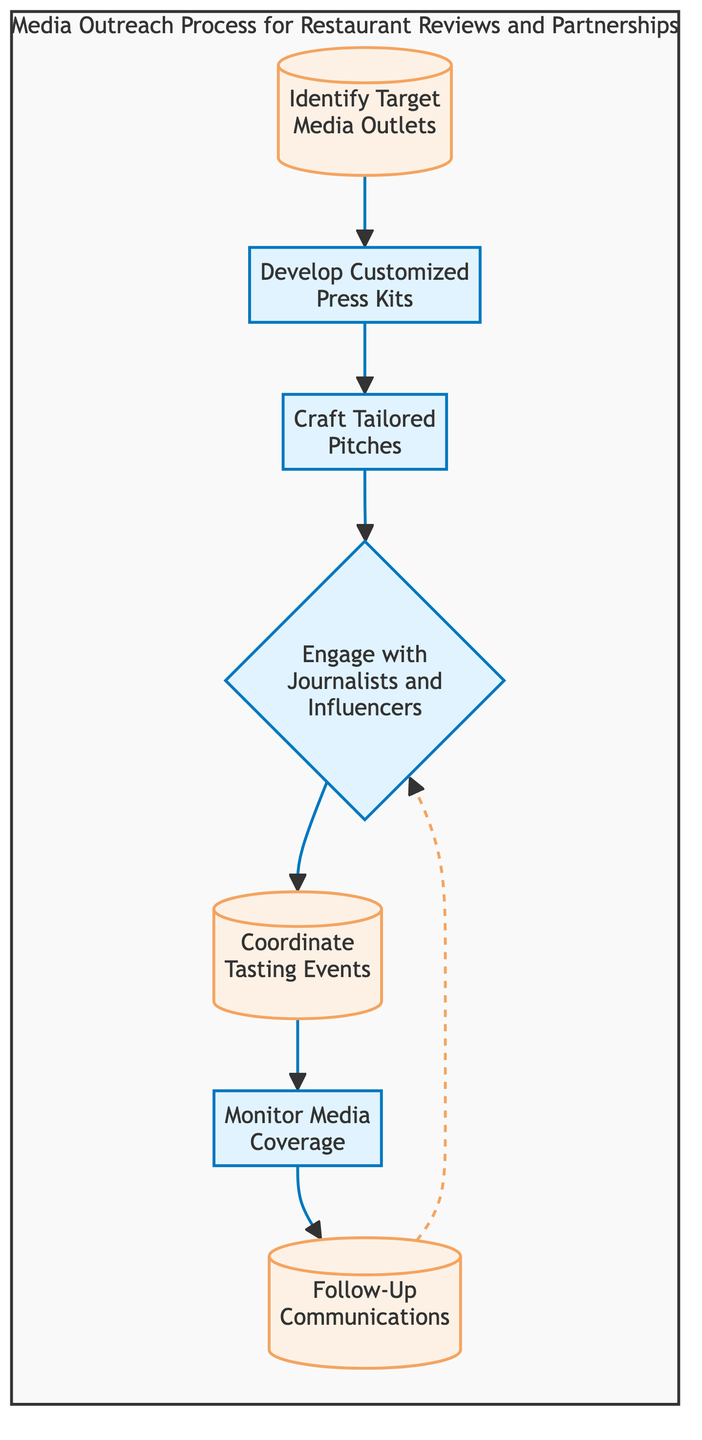What's the first step in the process? The diagram indicates that the first step in the media outreach process is "Identify Target Media Outlets." This can be determined by looking at the starting node in the flow chart.
Answer: Identify Target Media Outlets How many steps are in the outreach process? By counting the nodes in the diagram, there are a total of seven distinct steps involved in the outreach process.
Answer: 7 What is the last step in the process? The last step is labeled "Follow-Up Communications," which can be found at the end of the flowchart after all preceding steps have been completed.
Answer: Follow-Up Communications Which step involves organizing exclusive events? The step "Coordinate Tasting Events" specifically mentions the organization of exclusive tasting events for journalists and influencers, and it's a key part of the outreach process.
Answer: Coordinate Tasting Events What occurs after "Craft Tailored Pitches"? Following "Craft Tailored Pitches," the next step in the flowchart is "Engage with Journalists and Influencers," showing the flow of the process from one step to the next.
Answer: Engage with Journalists and Influencers Is there a feedback loop in the process? Yes, there is a dashed line returning from "Follow-Up Communications" to "Engage with Journalists and Influencers," indicating that ongoing relationships can lead back to further engagement opportunities.
Answer: Yes What type of relationship is depicted between "Monitor Media Coverage" and "Follow-Up Communications"? The relationship is shown as a dashed line, which implies a less direct connection, indicating that monitoring doesn't directly lead to follow-ups but can inform them.
Answer: Dashed line What is the purpose of "Develop Customized Press Kits"? This step's purpose is to create press kits highlighting unique features and offerings of the restaurants, providing essential information to media outlets.
Answer: Create press kits What is the role of "Engage with Journalists and Influencers"? The role of this step is to reach out to media contacts to establish relationships and share the media kits created in earlier steps, facilitating future cooperation.
Answer: Establish relationships 